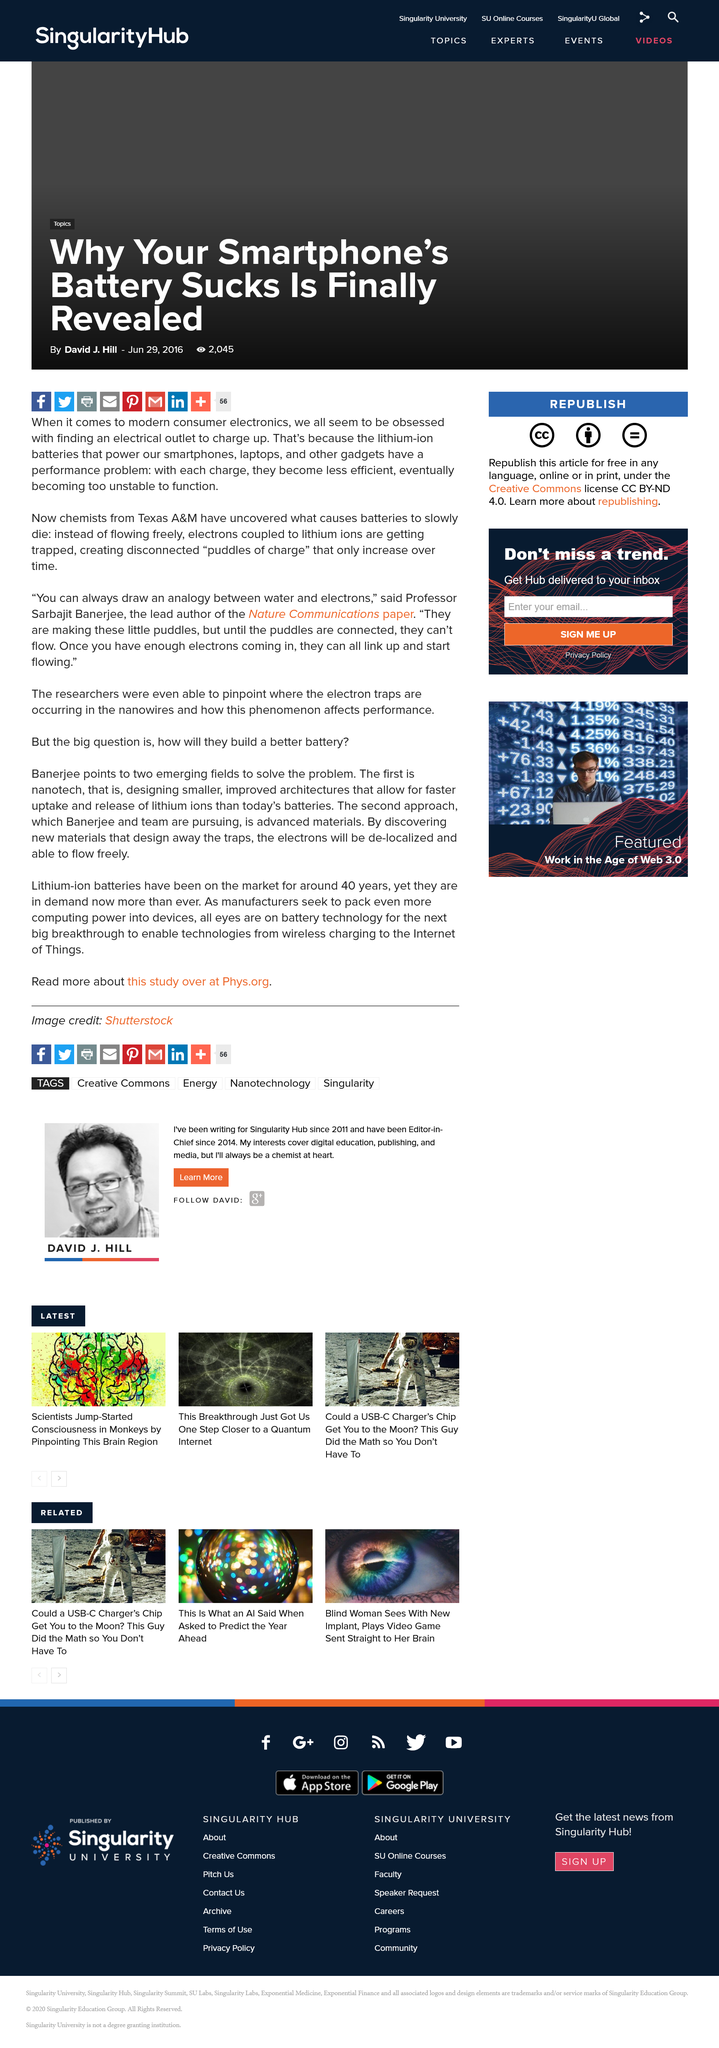Give some essential details in this illustration. Different factors can cause batteries to gradually lose their charge and eventually die. One of the main reasons is that electrons become trapped in the lithium ions, which disrupts the flow of electricity and causes the battery to deteriorate over time. The lead author of the Nature Communications paper is Sarbajit Banerjee. Lithium-ion batteries suffer from a comment problem where each charge results in decreased efficiency. 